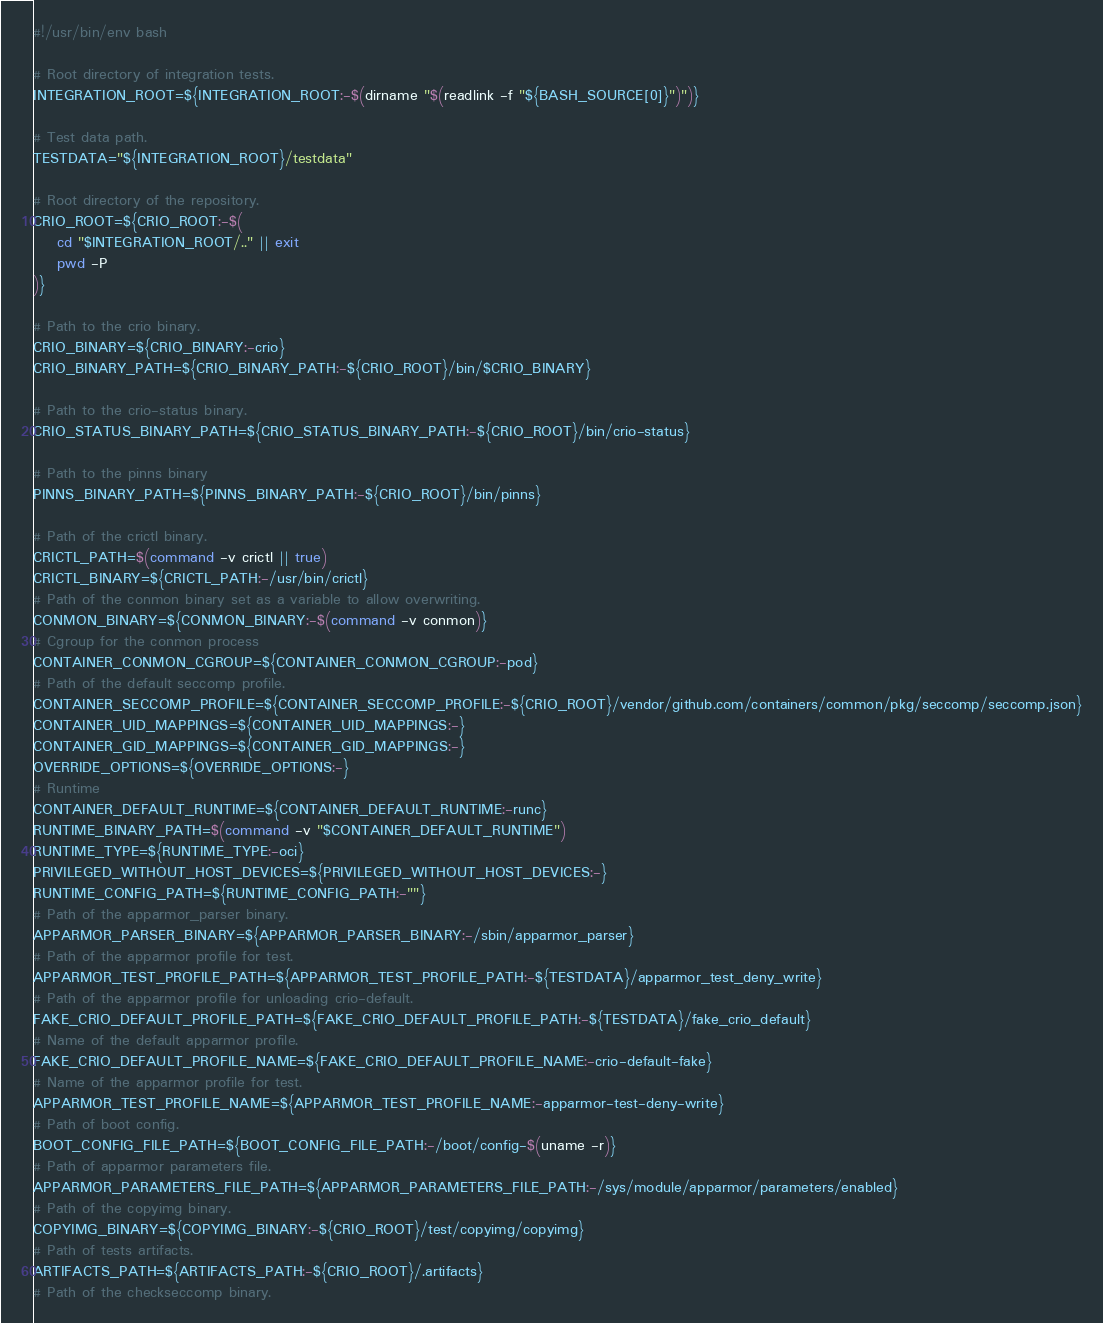<code> <loc_0><loc_0><loc_500><loc_500><_Bash_>#!/usr/bin/env bash

# Root directory of integration tests.
INTEGRATION_ROOT=${INTEGRATION_ROOT:-$(dirname "$(readlink -f "${BASH_SOURCE[0]}")")}

# Test data path.
TESTDATA="${INTEGRATION_ROOT}/testdata"

# Root directory of the repository.
CRIO_ROOT=${CRIO_ROOT:-$(
    cd "$INTEGRATION_ROOT/.." || exit
    pwd -P
)}

# Path to the crio binary.
CRIO_BINARY=${CRIO_BINARY:-crio}
CRIO_BINARY_PATH=${CRIO_BINARY_PATH:-${CRIO_ROOT}/bin/$CRIO_BINARY}

# Path to the crio-status binary.
CRIO_STATUS_BINARY_PATH=${CRIO_STATUS_BINARY_PATH:-${CRIO_ROOT}/bin/crio-status}

# Path to the pinns binary
PINNS_BINARY_PATH=${PINNS_BINARY_PATH:-${CRIO_ROOT}/bin/pinns}

# Path of the crictl binary.
CRICTL_PATH=$(command -v crictl || true)
CRICTL_BINARY=${CRICTL_PATH:-/usr/bin/crictl}
# Path of the conmon binary set as a variable to allow overwriting.
CONMON_BINARY=${CONMON_BINARY:-$(command -v conmon)}
# Cgroup for the conmon process
CONTAINER_CONMON_CGROUP=${CONTAINER_CONMON_CGROUP:-pod}
# Path of the default seccomp profile.
CONTAINER_SECCOMP_PROFILE=${CONTAINER_SECCOMP_PROFILE:-${CRIO_ROOT}/vendor/github.com/containers/common/pkg/seccomp/seccomp.json}
CONTAINER_UID_MAPPINGS=${CONTAINER_UID_MAPPINGS:-}
CONTAINER_GID_MAPPINGS=${CONTAINER_GID_MAPPINGS:-}
OVERRIDE_OPTIONS=${OVERRIDE_OPTIONS:-}
# Runtime
CONTAINER_DEFAULT_RUNTIME=${CONTAINER_DEFAULT_RUNTIME:-runc}
RUNTIME_BINARY_PATH=$(command -v "$CONTAINER_DEFAULT_RUNTIME")
RUNTIME_TYPE=${RUNTIME_TYPE:-oci}
PRIVILEGED_WITHOUT_HOST_DEVICES=${PRIVILEGED_WITHOUT_HOST_DEVICES:-}
RUNTIME_CONFIG_PATH=${RUNTIME_CONFIG_PATH:-""}
# Path of the apparmor_parser binary.
APPARMOR_PARSER_BINARY=${APPARMOR_PARSER_BINARY:-/sbin/apparmor_parser}
# Path of the apparmor profile for test.
APPARMOR_TEST_PROFILE_PATH=${APPARMOR_TEST_PROFILE_PATH:-${TESTDATA}/apparmor_test_deny_write}
# Path of the apparmor profile for unloading crio-default.
FAKE_CRIO_DEFAULT_PROFILE_PATH=${FAKE_CRIO_DEFAULT_PROFILE_PATH:-${TESTDATA}/fake_crio_default}
# Name of the default apparmor profile.
FAKE_CRIO_DEFAULT_PROFILE_NAME=${FAKE_CRIO_DEFAULT_PROFILE_NAME:-crio-default-fake}
# Name of the apparmor profile for test.
APPARMOR_TEST_PROFILE_NAME=${APPARMOR_TEST_PROFILE_NAME:-apparmor-test-deny-write}
# Path of boot config.
BOOT_CONFIG_FILE_PATH=${BOOT_CONFIG_FILE_PATH:-/boot/config-$(uname -r)}
# Path of apparmor parameters file.
APPARMOR_PARAMETERS_FILE_PATH=${APPARMOR_PARAMETERS_FILE_PATH:-/sys/module/apparmor/parameters/enabled}
# Path of the copyimg binary.
COPYIMG_BINARY=${COPYIMG_BINARY:-${CRIO_ROOT}/test/copyimg/copyimg}
# Path of tests artifacts.
ARTIFACTS_PATH=${ARTIFACTS_PATH:-${CRIO_ROOT}/.artifacts}
# Path of the checkseccomp binary.</code> 